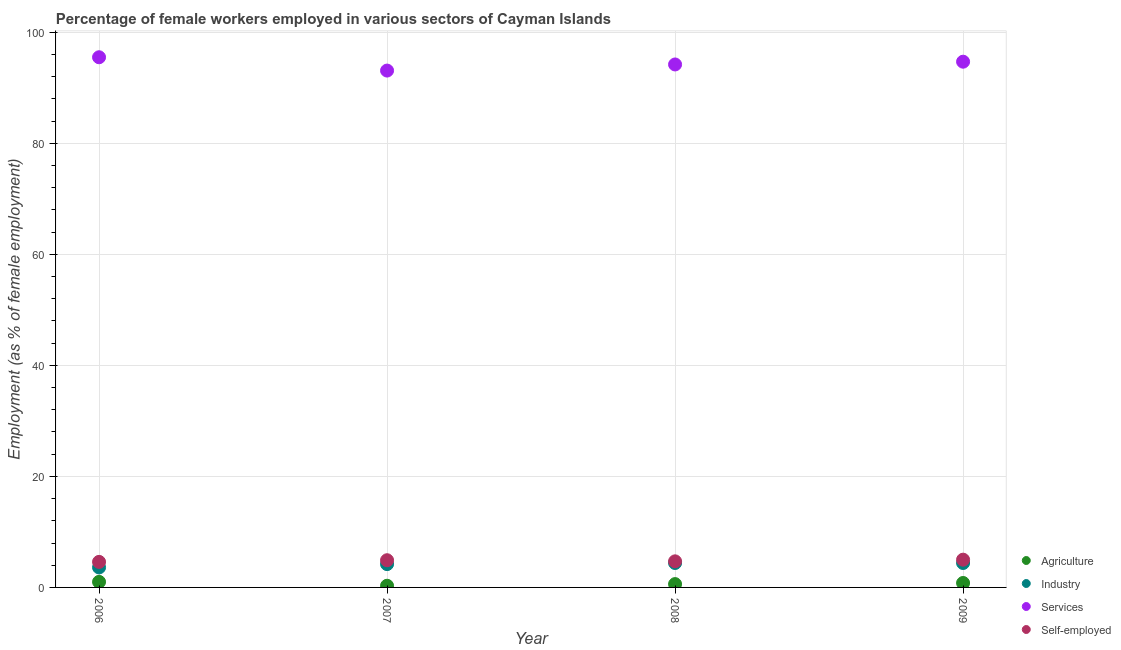Is the number of dotlines equal to the number of legend labels?
Provide a succinct answer. Yes. What is the percentage of female workers in agriculture in 2007?
Give a very brief answer. 0.3. Across all years, what is the maximum percentage of female workers in industry?
Provide a short and direct response. 4.4. Across all years, what is the minimum percentage of female workers in agriculture?
Your answer should be compact. 0.3. What is the total percentage of self employed female workers in the graph?
Offer a terse response. 19.2. What is the difference between the percentage of self employed female workers in 2007 and that in 2009?
Keep it short and to the point. -0.1. What is the difference between the percentage of self employed female workers in 2006 and the percentage of female workers in agriculture in 2008?
Your answer should be very brief. 4. What is the average percentage of self employed female workers per year?
Keep it short and to the point. 4.8. In the year 2006, what is the difference between the percentage of female workers in agriculture and percentage of self employed female workers?
Offer a very short reply. -3.6. What is the ratio of the percentage of self employed female workers in 2007 to that in 2009?
Your answer should be very brief. 0.98. What is the difference between the highest and the second highest percentage of female workers in agriculture?
Ensure brevity in your answer.  0.2. What is the difference between the highest and the lowest percentage of female workers in industry?
Make the answer very short. 0.8. In how many years, is the percentage of female workers in agriculture greater than the average percentage of female workers in agriculture taken over all years?
Make the answer very short. 2. Is it the case that in every year, the sum of the percentage of female workers in services and percentage of female workers in industry is greater than the sum of percentage of female workers in agriculture and percentage of self employed female workers?
Your answer should be very brief. Yes. Does the percentage of female workers in industry monotonically increase over the years?
Provide a succinct answer. No. Is the percentage of female workers in agriculture strictly greater than the percentage of female workers in services over the years?
Offer a terse response. No. Is the percentage of female workers in agriculture strictly less than the percentage of female workers in services over the years?
Your answer should be compact. Yes. How many dotlines are there?
Your answer should be very brief. 4. How many years are there in the graph?
Your answer should be very brief. 4. How are the legend labels stacked?
Provide a succinct answer. Vertical. What is the title of the graph?
Make the answer very short. Percentage of female workers employed in various sectors of Cayman Islands. What is the label or title of the X-axis?
Offer a terse response. Year. What is the label or title of the Y-axis?
Provide a short and direct response. Employment (as % of female employment). What is the Employment (as % of female employment) in Industry in 2006?
Your response must be concise. 3.6. What is the Employment (as % of female employment) in Services in 2006?
Your answer should be compact. 95.5. What is the Employment (as % of female employment) in Self-employed in 2006?
Provide a succinct answer. 4.6. What is the Employment (as % of female employment) in Agriculture in 2007?
Provide a succinct answer. 0.3. What is the Employment (as % of female employment) in Industry in 2007?
Offer a terse response. 4.2. What is the Employment (as % of female employment) of Services in 2007?
Offer a terse response. 93.1. What is the Employment (as % of female employment) in Self-employed in 2007?
Your answer should be very brief. 4.9. What is the Employment (as % of female employment) in Agriculture in 2008?
Provide a succinct answer. 0.6. What is the Employment (as % of female employment) of Industry in 2008?
Your answer should be compact. 4.4. What is the Employment (as % of female employment) in Services in 2008?
Make the answer very short. 94.2. What is the Employment (as % of female employment) of Self-employed in 2008?
Provide a short and direct response. 4.7. What is the Employment (as % of female employment) in Agriculture in 2009?
Offer a very short reply. 0.8. What is the Employment (as % of female employment) in Industry in 2009?
Offer a terse response. 4.4. What is the Employment (as % of female employment) in Services in 2009?
Provide a short and direct response. 94.7. What is the Employment (as % of female employment) in Self-employed in 2009?
Offer a very short reply. 5. Across all years, what is the maximum Employment (as % of female employment) in Agriculture?
Your response must be concise. 1. Across all years, what is the maximum Employment (as % of female employment) in Industry?
Offer a very short reply. 4.4. Across all years, what is the maximum Employment (as % of female employment) in Services?
Provide a succinct answer. 95.5. Across all years, what is the maximum Employment (as % of female employment) of Self-employed?
Your response must be concise. 5. Across all years, what is the minimum Employment (as % of female employment) of Agriculture?
Keep it short and to the point. 0.3. Across all years, what is the minimum Employment (as % of female employment) of Industry?
Make the answer very short. 3.6. Across all years, what is the minimum Employment (as % of female employment) of Services?
Keep it short and to the point. 93.1. Across all years, what is the minimum Employment (as % of female employment) in Self-employed?
Your answer should be very brief. 4.6. What is the total Employment (as % of female employment) in Industry in the graph?
Your response must be concise. 16.6. What is the total Employment (as % of female employment) of Services in the graph?
Provide a short and direct response. 377.5. What is the total Employment (as % of female employment) in Self-employed in the graph?
Offer a terse response. 19.2. What is the difference between the Employment (as % of female employment) in Agriculture in 2006 and that in 2007?
Ensure brevity in your answer.  0.7. What is the difference between the Employment (as % of female employment) in Agriculture in 2006 and that in 2008?
Keep it short and to the point. 0.4. What is the difference between the Employment (as % of female employment) of Industry in 2006 and that in 2008?
Ensure brevity in your answer.  -0.8. What is the difference between the Employment (as % of female employment) in Services in 2006 and that in 2008?
Offer a terse response. 1.3. What is the difference between the Employment (as % of female employment) in Self-employed in 2006 and that in 2008?
Provide a succinct answer. -0.1. What is the difference between the Employment (as % of female employment) of Agriculture in 2006 and that in 2009?
Make the answer very short. 0.2. What is the difference between the Employment (as % of female employment) in Industry in 2006 and that in 2009?
Ensure brevity in your answer.  -0.8. What is the difference between the Employment (as % of female employment) in Services in 2006 and that in 2009?
Ensure brevity in your answer.  0.8. What is the difference between the Employment (as % of female employment) in Agriculture in 2007 and that in 2008?
Ensure brevity in your answer.  -0.3. What is the difference between the Employment (as % of female employment) of Industry in 2007 and that in 2008?
Give a very brief answer. -0.2. What is the difference between the Employment (as % of female employment) of Services in 2007 and that in 2008?
Provide a succinct answer. -1.1. What is the difference between the Employment (as % of female employment) in Self-employed in 2007 and that in 2008?
Make the answer very short. 0.2. What is the difference between the Employment (as % of female employment) of Industry in 2007 and that in 2009?
Your answer should be very brief. -0.2. What is the difference between the Employment (as % of female employment) in Services in 2007 and that in 2009?
Ensure brevity in your answer.  -1.6. What is the difference between the Employment (as % of female employment) of Agriculture in 2008 and that in 2009?
Provide a succinct answer. -0.2. What is the difference between the Employment (as % of female employment) of Self-employed in 2008 and that in 2009?
Your answer should be very brief. -0.3. What is the difference between the Employment (as % of female employment) in Agriculture in 2006 and the Employment (as % of female employment) in Industry in 2007?
Make the answer very short. -3.2. What is the difference between the Employment (as % of female employment) in Agriculture in 2006 and the Employment (as % of female employment) in Services in 2007?
Offer a terse response. -92.1. What is the difference between the Employment (as % of female employment) of Industry in 2006 and the Employment (as % of female employment) of Services in 2007?
Your response must be concise. -89.5. What is the difference between the Employment (as % of female employment) of Industry in 2006 and the Employment (as % of female employment) of Self-employed in 2007?
Your answer should be very brief. -1.3. What is the difference between the Employment (as % of female employment) in Services in 2006 and the Employment (as % of female employment) in Self-employed in 2007?
Ensure brevity in your answer.  90.6. What is the difference between the Employment (as % of female employment) of Agriculture in 2006 and the Employment (as % of female employment) of Industry in 2008?
Offer a very short reply. -3.4. What is the difference between the Employment (as % of female employment) in Agriculture in 2006 and the Employment (as % of female employment) in Services in 2008?
Ensure brevity in your answer.  -93.2. What is the difference between the Employment (as % of female employment) of Industry in 2006 and the Employment (as % of female employment) of Services in 2008?
Offer a terse response. -90.6. What is the difference between the Employment (as % of female employment) of Industry in 2006 and the Employment (as % of female employment) of Self-employed in 2008?
Your response must be concise. -1.1. What is the difference between the Employment (as % of female employment) of Services in 2006 and the Employment (as % of female employment) of Self-employed in 2008?
Ensure brevity in your answer.  90.8. What is the difference between the Employment (as % of female employment) of Agriculture in 2006 and the Employment (as % of female employment) of Industry in 2009?
Provide a succinct answer. -3.4. What is the difference between the Employment (as % of female employment) in Agriculture in 2006 and the Employment (as % of female employment) in Services in 2009?
Offer a terse response. -93.7. What is the difference between the Employment (as % of female employment) of Agriculture in 2006 and the Employment (as % of female employment) of Self-employed in 2009?
Ensure brevity in your answer.  -4. What is the difference between the Employment (as % of female employment) of Industry in 2006 and the Employment (as % of female employment) of Services in 2009?
Provide a succinct answer. -91.1. What is the difference between the Employment (as % of female employment) in Services in 2006 and the Employment (as % of female employment) in Self-employed in 2009?
Provide a succinct answer. 90.5. What is the difference between the Employment (as % of female employment) of Agriculture in 2007 and the Employment (as % of female employment) of Industry in 2008?
Ensure brevity in your answer.  -4.1. What is the difference between the Employment (as % of female employment) in Agriculture in 2007 and the Employment (as % of female employment) in Services in 2008?
Your answer should be compact. -93.9. What is the difference between the Employment (as % of female employment) of Industry in 2007 and the Employment (as % of female employment) of Services in 2008?
Give a very brief answer. -90. What is the difference between the Employment (as % of female employment) in Services in 2007 and the Employment (as % of female employment) in Self-employed in 2008?
Give a very brief answer. 88.4. What is the difference between the Employment (as % of female employment) in Agriculture in 2007 and the Employment (as % of female employment) in Industry in 2009?
Provide a succinct answer. -4.1. What is the difference between the Employment (as % of female employment) in Agriculture in 2007 and the Employment (as % of female employment) in Services in 2009?
Your answer should be very brief. -94.4. What is the difference between the Employment (as % of female employment) in Agriculture in 2007 and the Employment (as % of female employment) in Self-employed in 2009?
Your answer should be very brief. -4.7. What is the difference between the Employment (as % of female employment) in Industry in 2007 and the Employment (as % of female employment) in Services in 2009?
Your response must be concise. -90.5. What is the difference between the Employment (as % of female employment) of Industry in 2007 and the Employment (as % of female employment) of Self-employed in 2009?
Keep it short and to the point. -0.8. What is the difference between the Employment (as % of female employment) in Services in 2007 and the Employment (as % of female employment) in Self-employed in 2009?
Offer a very short reply. 88.1. What is the difference between the Employment (as % of female employment) of Agriculture in 2008 and the Employment (as % of female employment) of Services in 2009?
Give a very brief answer. -94.1. What is the difference between the Employment (as % of female employment) of Industry in 2008 and the Employment (as % of female employment) of Services in 2009?
Offer a terse response. -90.3. What is the difference between the Employment (as % of female employment) of Services in 2008 and the Employment (as % of female employment) of Self-employed in 2009?
Offer a terse response. 89.2. What is the average Employment (as % of female employment) of Agriculture per year?
Offer a very short reply. 0.68. What is the average Employment (as % of female employment) in Industry per year?
Keep it short and to the point. 4.15. What is the average Employment (as % of female employment) in Services per year?
Provide a succinct answer. 94.38. In the year 2006, what is the difference between the Employment (as % of female employment) in Agriculture and Employment (as % of female employment) in Industry?
Provide a succinct answer. -2.6. In the year 2006, what is the difference between the Employment (as % of female employment) of Agriculture and Employment (as % of female employment) of Services?
Give a very brief answer. -94.5. In the year 2006, what is the difference between the Employment (as % of female employment) of Industry and Employment (as % of female employment) of Services?
Your response must be concise. -91.9. In the year 2006, what is the difference between the Employment (as % of female employment) of Industry and Employment (as % of female employment) of Self-employed?
Your answer should be compact. -1. In the year 2006, what is the difference between the Employment (as % of female employment) in Services and Employment (as % of female employment) in Self-employed?
Provide a short and direct response. 90.9. In the year 2007, what is the difference between the Employment (as % of female employment) of Agriculture and Employment (as % of female employment) of Industry?
Your answer should be very brief. -3.9. In the year 2007, what is the difference between the Employment (as % of female employment) in Agriculture and Employment (as % of female employment) in Services?
Your answer should be compact. -92.8. In the year 2007, what is the difference between the Employment (as % of female employment) in Industry and Employment (as % of female employment) in Services?
Provide a succinct answer. -88.9. In the year 2007, what is the difference between the Employment (as % of female employment) of Services and Employment (as % of female employment) of Self-employed?
Offer a very short reply. 88.2. In the year 2008, what is the difference between the Employment (as % of female employment) in Agriculture and Employment (as % of female employment) in Services?
Ensure brevity in your answer.  -93.6. In the year 2008, what is the difference between the Employment (as % of female employment) in Industry and Employment (as % of female employment) in Services?
Your response must be concise. -89.8. In the year 2008, what is the difference between the Employment (as % of female employment) in Industry and Employment (as % of female employment) in Self-employed?
Make the answer very short. -0.3. In the year 2008, what is the difference between the Employment (as % of female employment) in Services and Employment (as % of female employment) in Self-employed?
Provide a short and direct response. 89.5. In the year 2009, what is the difference between the Employment (as % of female employment) of Agriculture and Employment (as % of female employment) of Services?
Ensure brevity in your answer.  -93.9. In the year 2009, what is the difference between the Employment (as % of female employment) in Industry and Employment (as % of female employment) in Services?
Offer a very short reply. -90.3. In the year 2009, what is the difference between the Employment (as % of female employment) of Industry and Employment (as % of female employment) of Self-employed?
Offer a terse response. -0.6. In the year 2009, what is the difference between the Employment (as % of female employment) of Services and Employment (as % of female employment) of Self-employed?
Offer a very short reply. 89.7. What is the ratio of the Employment (as % of female employment) in Services in 2006 to that in 2007?
Your answer should be very brief. 1.03. What is the ratio of the Employment (as % of female employment) of Self-employed in 2006 to that in 2007?
Your answer should be very brief. 0.94. What is the ratio of the Employment (as % of female employment) in Industry in 2006 to that in 2008?
Offer a terse response. 0.82. What is the ratio of the Employment (as % of female employment) of Services in 2006 to that in 2008?
Your response must be concise. 1.01. What is the ratio of the Employment (as % of female employment) of Self-employed in 2006 to that in 2008?
Provide a succinct answer. 0.98. What is the ratio of the Employment (as % of female employment) in Industry in 2006 to that in 2009?
Ensure brevity in your answer.  0.82. What is the ratio of the Employment (as % of female employment) of Services in 2006 to that in 2009?
Provide a short and direct response. 1.01. What is the ratio of the Employment (as % of female employment) in Industry in 2007 to that in 2008?
Ensure brevity in your answer.  0.95. What is the ratio of the Employment (as % of female employment) in Services in 2007 to that in 2008?
Make the answer very short. 0.99. What is the ratio of the Employment (as % of female employment) in Self-employed in 2007 to that in 2008?
Ensure brevity in your answer.  1.04. What is the ratio of the Employment (as % of female employment) of Industry in 2007 to that in 2009?
Make the answer very short. 0.95. What is the ratio of the Employment (as % of female employment) in Services in 2007 to that in 2009?
Provide a succinct answer. 0.98. What is the ratio of the Employment (as % of female employment) of Industry in 2008 to that in 2009?
Keep it short and to the point. 1. What is the ratio of the Employment (as % of female employment) in Services in 2008 to that in 2009?
Your response must be concise. 0.99. What is the difference between the highest and the second highest Employment (as % of female employment) of Services?
Keep it short and to the point. 0.8. What is the difference between the highest and the lowest Employment (as % of female employment) of Industry?
Offer a terse response. 0.8. What is the difference between the highest and the lowest Employment (as % of female employment) of Services?
Your answer should be very brief. 2.4. 